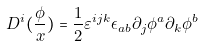Convert formula to latex. <formula><loc_0><loc_0><loc_500><loc_500>D ^ { i } ( \frac { \phi } { x } ) = \frac { 1 } { 2 } \varepsilon ^ { i j k } \epsilon _ { a b } \partial _ { j } \phi ^ { a } \partial _ { k } \phi ^ { b }</formula> 